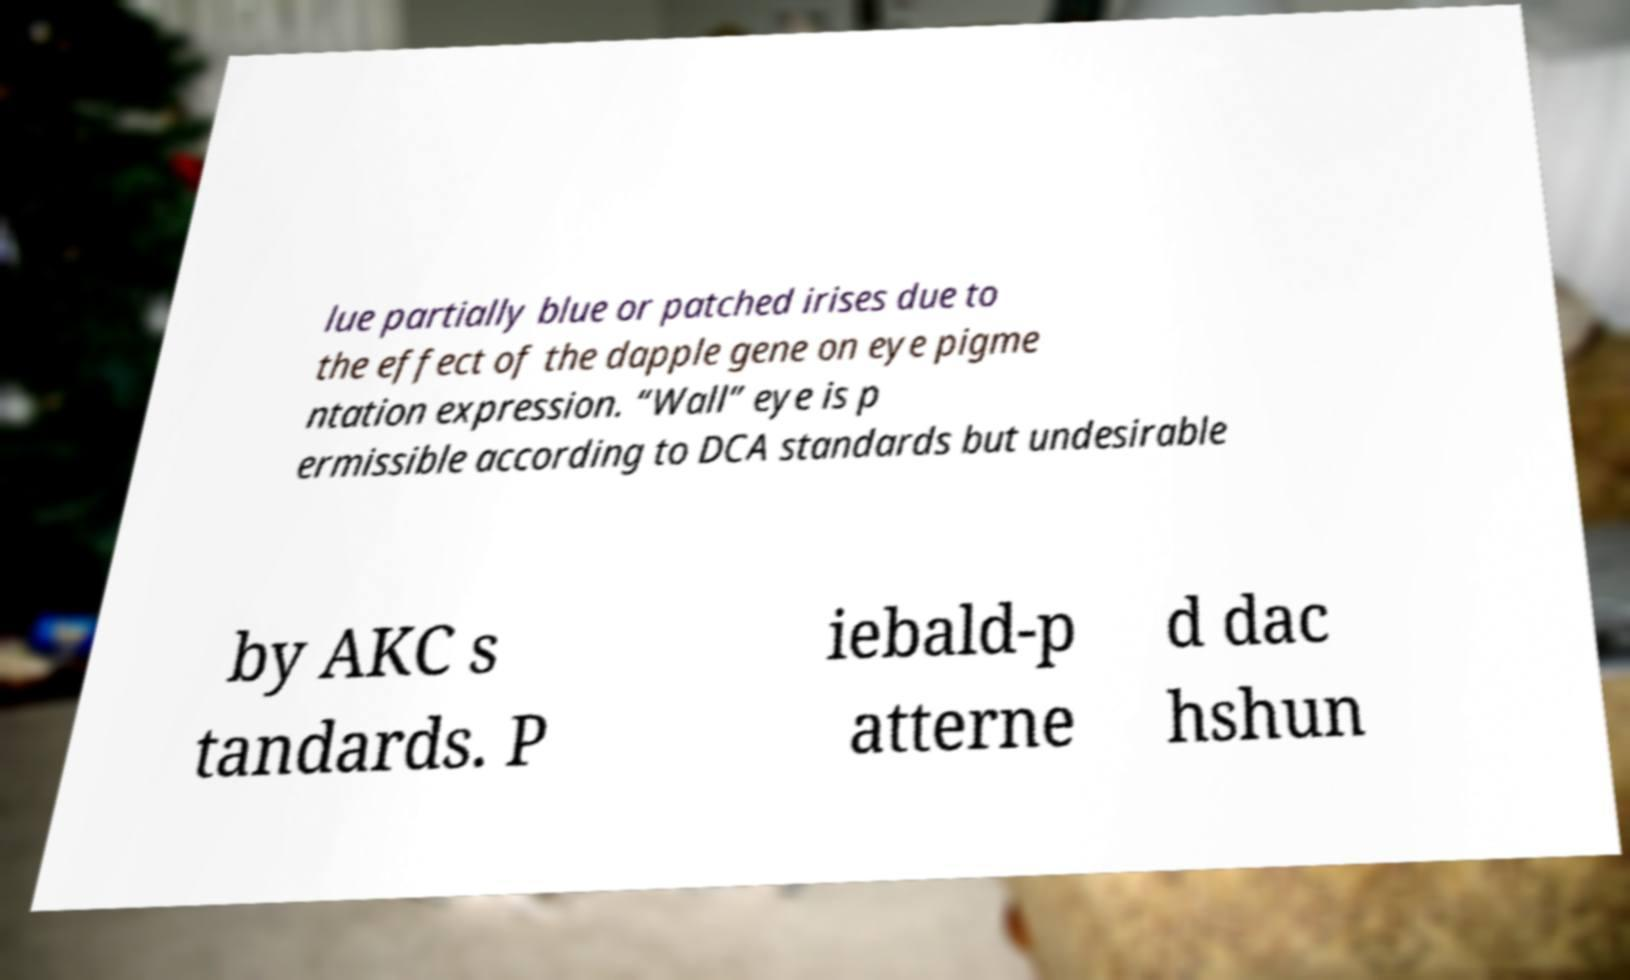Could you extract and type out the text from this image? lue partially blue or patched irises due to the effect of the dapple gene on eye pigme ntation expression. “Wall” eye is p ermissible according to DCA standards but undesirable by AKC s tandards. P iebald-p atterne d dac hshun 